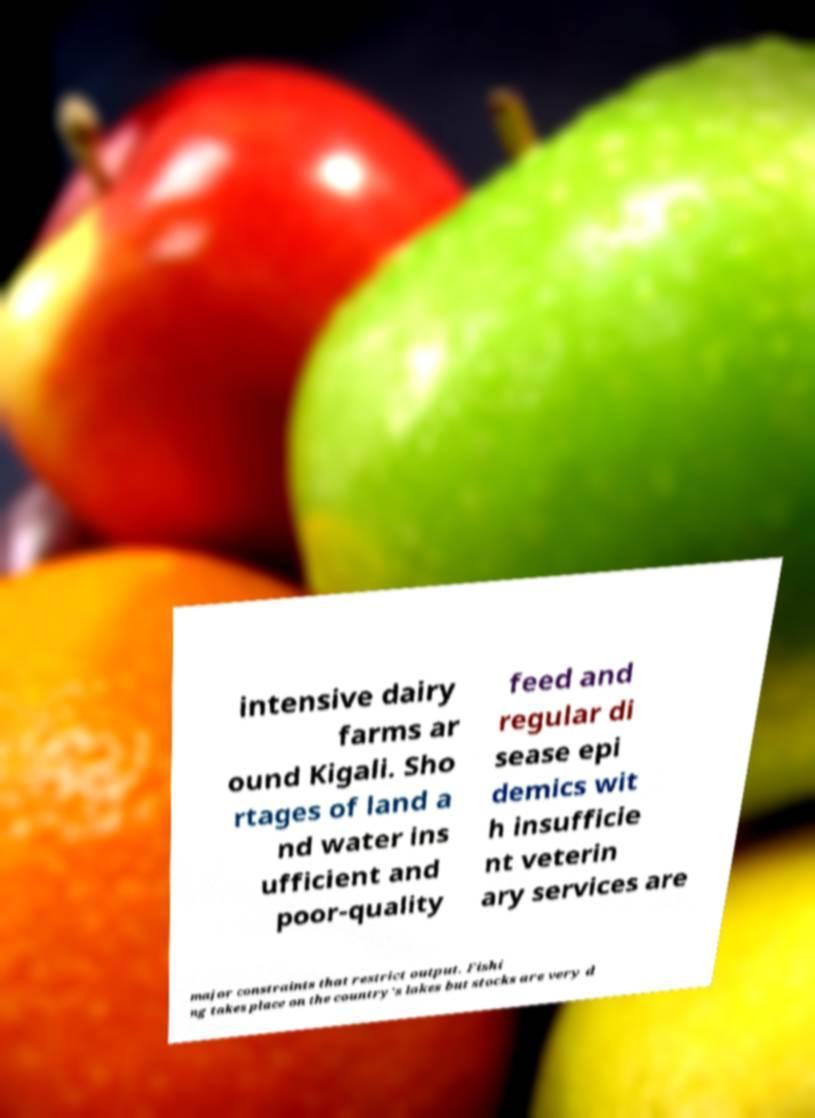For documentation purposes, I need the text within this image transcribed. Could you provide that? intensive dairy farms ar ound Kigali. Sho rtages of land a nd water ins ufficient and poor-quality feed and regular di sease epi demics wit h insufficie nt veterin ary services are major constraints that restrict output. Fishi ng takes place on the country's lakes but stocks are very d 